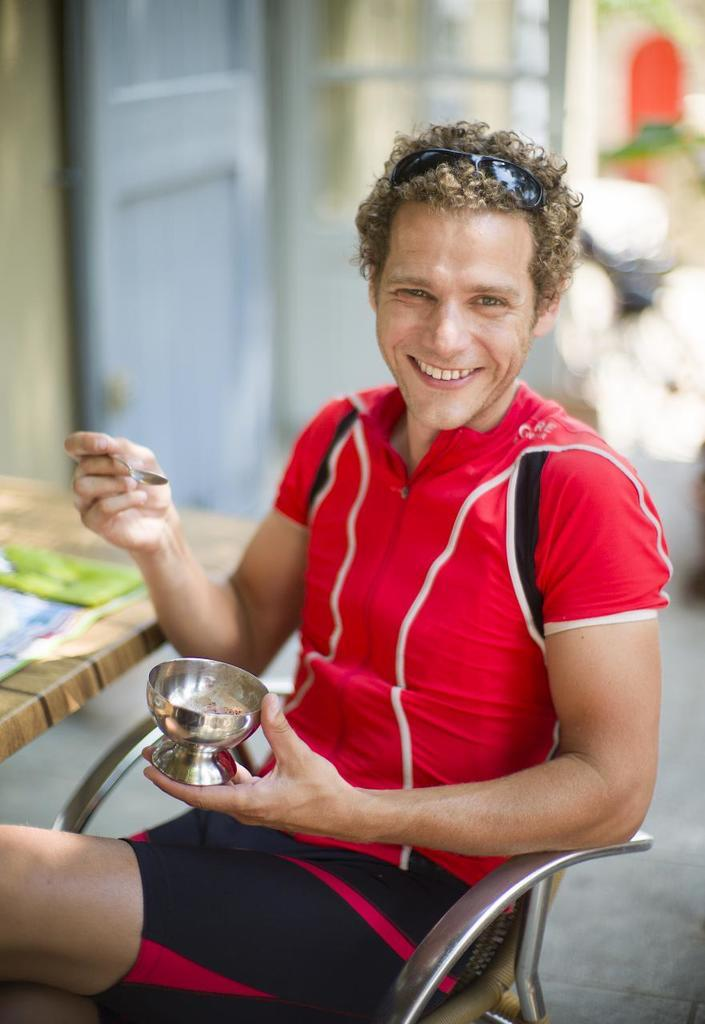What is present in the image? There is a person in the image. What is the person doing in the image? The person is holding an object and sitting on a chair. What type of basket is visible in the image? There is no basket present in the image. What type of slip is the person wearing in the image? There is no information about the person's clothing in the image. 